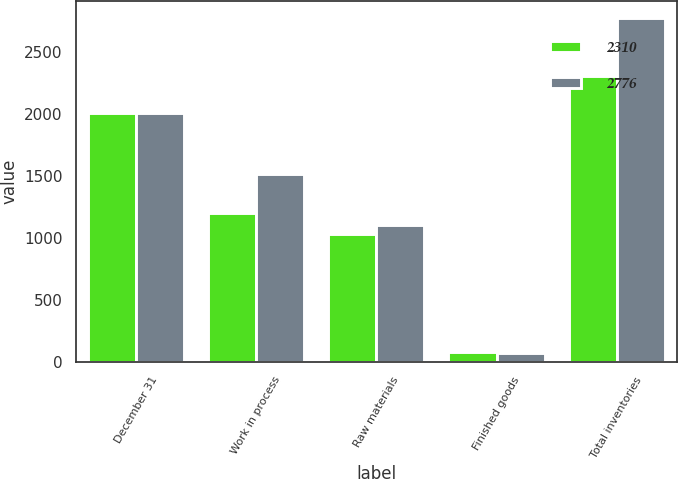Convert chart. <chart><loc_0><loc_0><loc_500><loc_500><stacked_bar_chart><ecel><fcel>December 31<fcel>Work in process<fcel>Raw materials<fcel>Finished goods<fcel>Total inventories<nl><fcel>2310<fcel>2011<fcel>1202<fcel>1031<fcel>77<fcel>2310<nl><fcel>2776<fcel>2012<fcel>1518<fcel>1109<fcel>69<fcel>2776<nl></chart> 